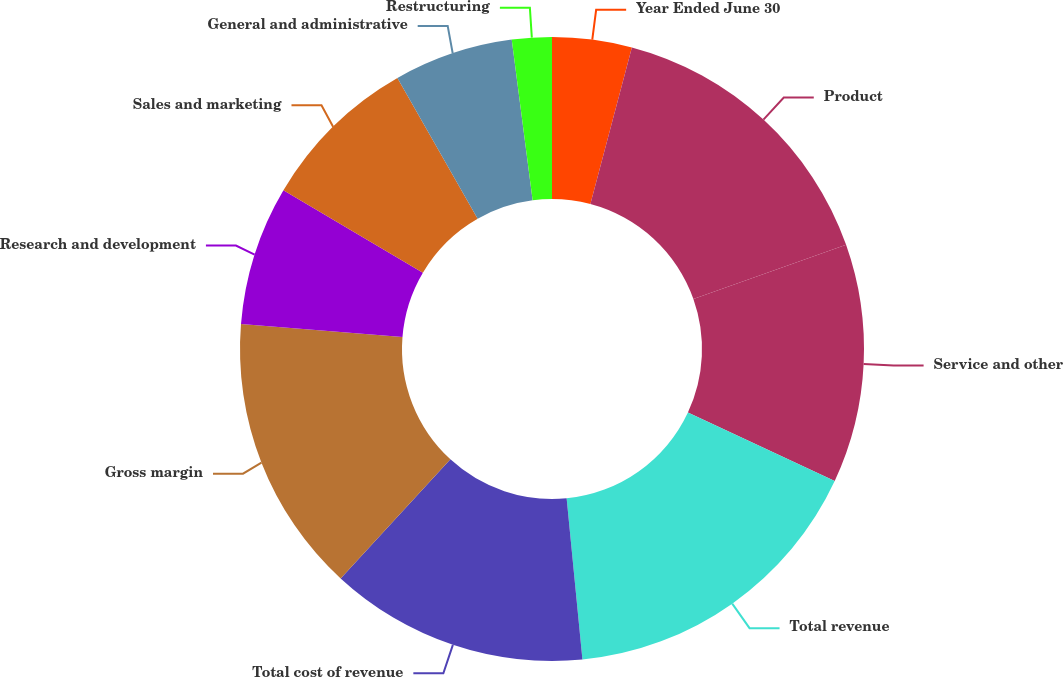Convert chart to OTSL. <chart><loc_0><loc_0><loc_500><loc_500><pie_chart><fcel>Year Ended June 30<fcel>Product<fcel>Service and other<fcel>Total revenue<fcel>Total cost of revenue<fcel>Gross margin<fcel>Research and development<fcel>Sales and marketing<fcel>General and administrative<fcel>Restructuring<nl><fcel>4.12%<fcel>15.46%<fcel>12.37%<fcel>16.49%<fcel>13.4%<fcel>14.43%<fcel>7.22%<fcel>8.25%<fcel>6.19%<fcel>2.06%<nl></chart> 